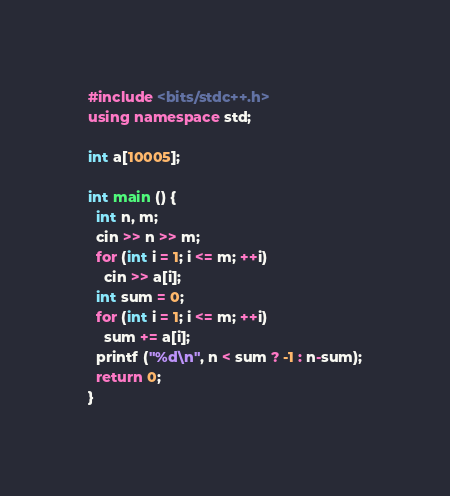Convert code to text. <code><loc_0><loc_0><loc_500><loc_500><_C++_>#include <bits/stdc++.h>
using namespace std;

int a[10005];

int main () {
  int n, m;
  cin >> n >> m;
  for (int i = 1; i <= m; ++i)
    cin >> a[i];
  int sum = 0;
  for (int i = 1; i <= m; ++i)
    sum += a[i];
  printf ("%d\n", n < sum ? -1 : n-sum);
  return 0;
}</code> 